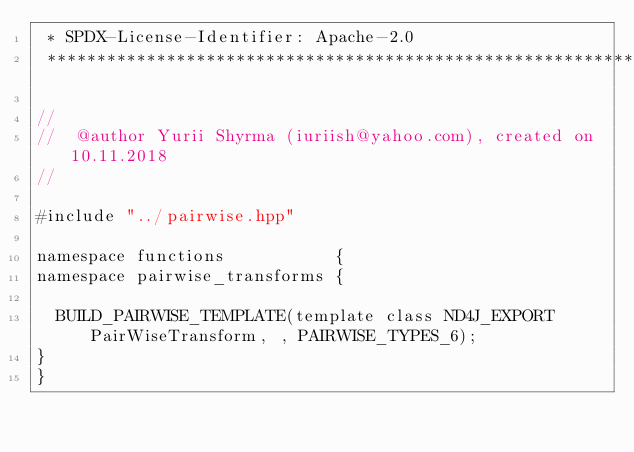<code> <loc_0><loc_0><loc_500><loc_500><_Cuda_> * SPDX-License-Identifier: Apache-2.0
 ******************************************************************************/

//
//  @author Yurii Shyrma (iuriish@yahoo.com), created on 10.11.2018
//

#include "../pairwise.hpp"

namespace functions           {
namespace pairwise_transforms {

	BUILD_PAIRWISE_TEMPLATE(template class ND4J_EXPORT PairWiseTransform, , PAIRWISE_TYPES_6);
}
}</code> 